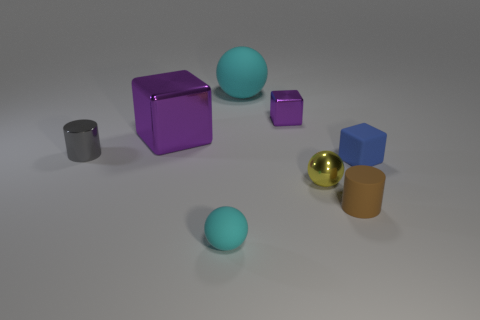Add 1 brown shiny things. How many objects exist? 9 Subtract all cubes. How many objects are left? 5 Subtract all blue shiny cubes. Subtract all small yellow objects. How many objects are left? 7 Add 6 yellow things. How many yellow things are left? 7 Add 3 tiny matte balls. How many tiny matte balls exist? 4 Subtract 1 gray cylinders. How many objects are left? 7 